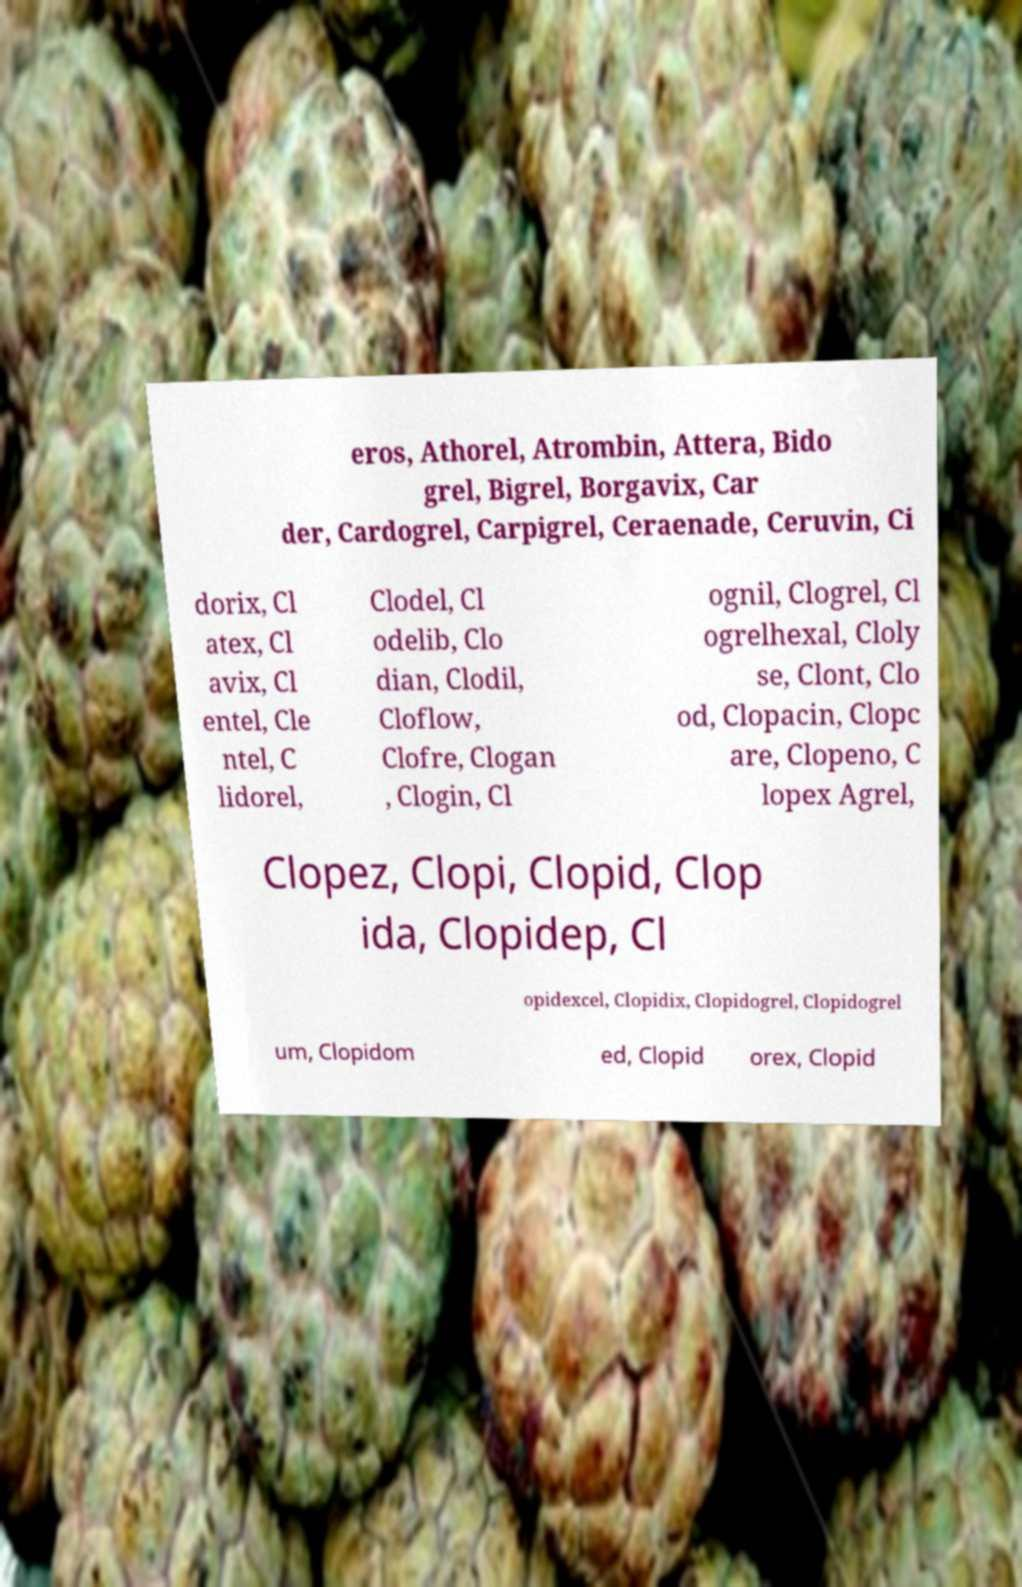What messages or text are displayed in this image? I need them in a readable, typed format. eros, Athorel, Atrombin, Attera, Bido grel, Bigrel, Borgavix, Car der, Cardogrel, Carpigrel, Ceraenade, Ceruvin, Ci dorix, Cl atex, Cl avix, Cl entel, Cle ntel, C lidorel, Clodel, Cl odelib, Clo dian, Clodil, Cloflow, Clofre, Clogan , Clogin, Cl ognil, Clogrel, Cl ogrelhexal, Cloly se, Clont, Clo od, Clopacin, Clopc are, Clopeno, C lopex Agrel, Clopez, Clopi, Clopid, Clop ida, Clopidep, Cl opidexcel, Clopidix, Clopidogrel, Clopidogrel um, Clopidom ed, Clopid orex, Clopid 